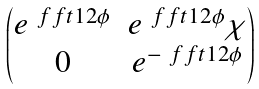<formula> <loc_0><loc_0><loc_500><loc_500>\begin{pmatrix} e ^ { \ f f t 1 2 \phi } & e ^ { \ f f t 1 2 \phi } \chi \\ 0 & e ^ { - \ f f t 1 2 \phi } \end{pmatrix}</formula> 